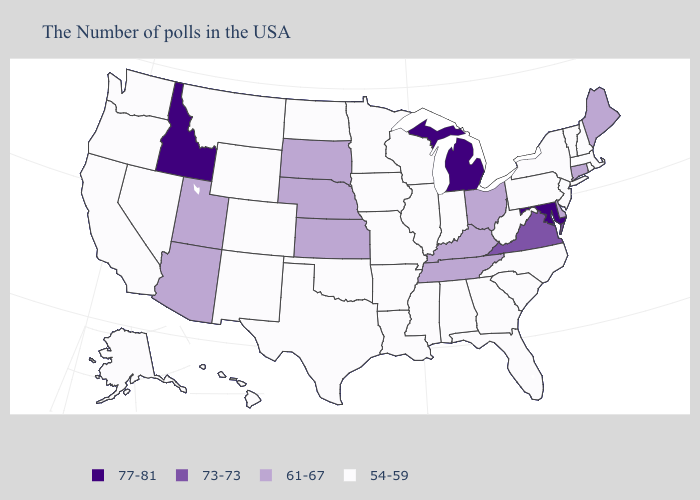What is the highest value in the USA?
Concise answer only. 77-81. Does New Jersey have a lower value than Virginia?
Quick response, please. Yes. Name the states that have a value in the range 77-81?
Quick response, please. Maryland, Michigan, Idaho. Which states have the highest value in the USA?
Give a very brief answer. Maryland, Michigan, Idaho. Which states have the lowest value in the USA?
Short answer required. Massachusetts, Rhode Island, New Hampshire, Vermont, New York, New Jersey, Pennsylvania, North Carolina, South Carolina, West Virginia, Florida, Georgia, Indiana, Alabama, Wisconsin, Illinois, Mississippi, Louisiana, Missouri, Arkansas, Minnesota, Iowa, Oklahoma, Texas, North Dakota, Wyoming, Colorado, New Mexico, Montana, Nevada, California, Washington, Oregon, Alaska, Hawaii. Does the first symbol in the legend represent the smallest category?
Short answer required. No. What is the lowest value in states that border New York?
Be succinct. 54-59. Does Kansas have the lowest value in the USA?
Write a very short answer. No. How many symbols are there in the legend?
Short answer required. 4. Does the map have missing data?
Answer briefly. No. What is the value of Hawaii?
Give a very brief answer. 54-59. Does the map have missing data?
Keep it brief. No. Name the states that have a value in the range 54-59?
Concise answer only. Massachusetts, Rhode Island, New Hampshire, Vermont, New York, New Jersey, Pennsylvania, North Carolina, South Carolina, West Virginia, Florida, Georgia, Indiana, Alabama, Wisconsin, Illinois, Mississippi, Louisiana, Missouri, Arkansas, Minnesota, Iowa, Oklahoma, Texas, North Dakota, Wyoming, Colorado, New Mexico, Montana, Nevada, California, Washington, Oregon, Alaska, Hawaii. What is the highest value in the South ?
Keep it brief. 77-81. Among the states that border Idaho , which have the highest value?
Keep it brief. Utah. 